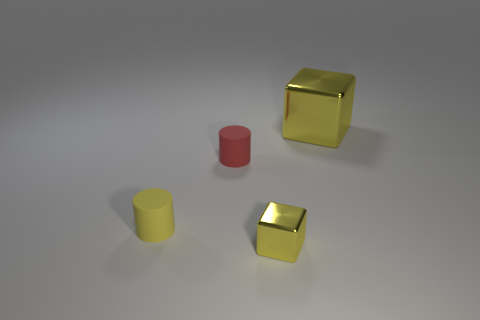What number of rubber things are either large yellow objects or tiny blue balls?
Ensure brevity in your answer.  0. There is a rubber thing right of the yellow matte thing; is its shape the same as the large object?
Provide a succinct answer. No. Are there more tiny things that are behind the tiny yellow cube than small matte spheres?
Make the answer very short. Yes. What number of yellow objects are both to the right of the tiny yellow metal thing and on the left side of the red rubber object?
Offer a terse response. 0. What color is the object that is right of the yellow shiny thing in front of the large yellow shiny thing?
Give a very brief answer. Yellow. What number of rubber things have the same color as the small metal object?
Your response must be concise. 1. Does the small block have the same color as the rubber object that is in front of the small red rubber cylinder?
Make the answer very short. Yes. Is the number of yellow shiny cubes less than the number of small gray shiny things?
Ensure brevity in your answer.  No. Are there more cylinders that are right of the tiny metallic object than tiny yellow rubber objects on the right side of the big yellow shiny block?
Your response must be concise. No. Are the tiny block and the tiny red cylinder made of the same material?
Your answer should be very brief. No. 